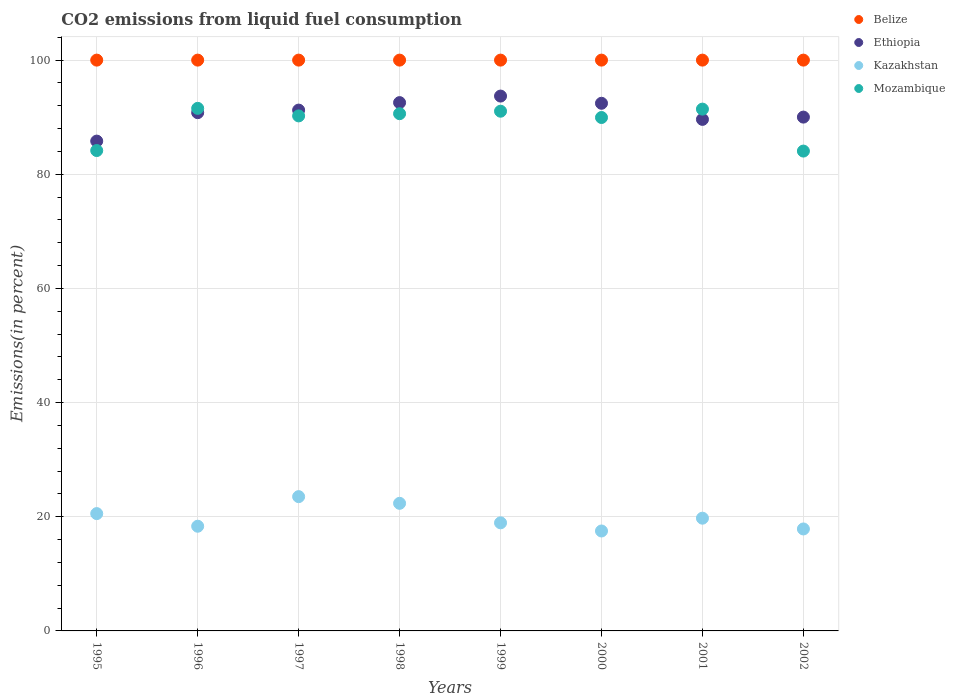What is the total CO2 emitted in Kazakhstan in 1999?
Provide a short and direct response. 18.94. Across all years, what is the maximum total CO2 emitted in Mozambique?
Ensure brevity in your answer.  91.55. Across all years, what is the minimum total CO2 emitted in Mozambique?
Your response must be concise. 84.06. What is the total total CO2 emitted in Belize in the graph?
Make the answer very short. 800. What is the difference between the total CO2 emitted in Ethiopia in 1997 and that in 2001?
Your answer should be compact. 1.63. What is the difference between the total CO2 emitted in Ethiopia in 1999 and the total CO2 emitted in Kazakhstan in 2001?
Give a very brief answer. 73.95. What is the average total CO2 emitted in Mozambique per year?
Keep it short and to the point. 89.13. In the year 1998, what is the difference between the total CO2 emitted in Ethiopia and total CO2 emitted in Kazakhstan?
Your answer should be very brief. 70.2. In how many years, is the total CO2 emitted in Kazakhstan greater than 32 %?
Keep it short and to the point. 0. What is the ratio of the total CO2 emitted in Kazakhstan in 1996 to that in 2001?
Your answer should be compact. 0.93. Is the total CO2 emitted in Mozambique in 1996 less than that in 2000?
Ensure brevity in your answer.  No. Is the difference between the total CO2 emitted in Ethiopia in 1999 and 2002 greater than the difference between the total CO2 emitted in Kazakhstan in 1999 and 2002?
Offer a very short reply. Yes. What is the difference between the highest and the second highest total CO2 emitted in Mozambique?
Offer a very short reply. 0.13. What is the difference between the highest and the lowest total CO2 emitted in Kazakhstan?
Give a very brief answer. 6.02. In how many years, is the total CO2 emitted in Kazakhstan greater than the average total CO2 emitted in Kazakhstan taken over all years?
Your answer should be very brief. 3. Is the sum of the total CO2 emitted in Kazakhstan in 2000 and 2001 greater than the maximum total CO2 emitted in Belize across all years?
Ensure brevity in your answer.  No. Is it the case that in every year, the sum of the total CO2 emitted in Ethiopia and total CO2 emitted in Kazakhstan  is greater than the sum of total CO2 emitted in Belize and total CO2 emitted in Mozambique?
Make the answer very short. Yes. Does the total CO2 emitted in Kazakhstan monotonically increase over the years?
Offer a very short reply. No. Is the total CO2 emitted in Ethiopia strictly greater than the total CO2 emitted in Mozambique over the years?
Offer a very short reply. No. Is the total CO2 emitted in Kazakhstan strictly less than the total CO2 emitted in Belize over the years?
Offer a terse response. Yes. How many dotlines are there?
Ensure brevity in your answer.  4. What is the difference between two consecutive major ticks on the Y-axis?
Your response must be concise. 20. Are the values on the major ticks of Y-axis written in scientific E-notation?
Give a very brief answer. No. Does the graph contain grids?
Make the answer very short. Yes. Where does the legend appear in the graph?
Provide a short and direct response. Top right. How many legend labels are there?
Make the answer very short. 4. What is the title of the graph?
Your answer should be very brief. CO2 emissions from liquid fuel consumption. Does "Fiji" appear as one of the legend labels in the graph?
Your answer should be very brief. No. What is the label or title of the Y-axis?
Your answer should be compact. Emissions(in percent). What is the Emissions(in percent) in Belize in 1995?
Your answer should be compact. 100. What is the Emissions(in percent) in Ethiopia in 1995?
Provide a succinct answer. 85.81. What is the Emissions(in percent) in Kazakhstan in 1995?
Make the answer very short. 20.55. What is the Emissions(in percent) of Mozambique in 1995?
Offer a very short reply. 84.16. What is the Emissions(in percent) in Belize in 1996?
Offer a terse response. 100. What is the Emissions(in percent) in Ethiopia in 1996?
Offer a terse response. 90.79. What is the Emissions(in percent) in Kazakhstan in 1996?
Offer a terse response. 18.34. What is the Emissions(in percent) of Mozambique in 1996?
Provide a short and direct response. 91.55. What is the Emissions(in percent) in Belize in 1997?
Provide a succinct answer. 100. What is the Emissions(in percent) in Ethiopia in 1997?
Your response must be concise. 91.24. What is the Emissions(in percent) of Kazakhstan in 1997?
Give a very brief answer. 23.52. What is the Emissions(in percent) of Mozambique in 1997?
Your answer should be very brief. 90.23. What is the Emissions(in percent) of Belize in 1998?
Provide a succinct answer. 100. What is the Emissions(in percent) of Ethiopia in 1998?
Your answer should be compact. 92.55. What is the Emissions(in percent) in Kazakhstan in 1998?
Make the answer very short. 22.35. What is the Emissions(in percent) in Mozambique in 1998?
Keep it short and to the point. 90.61. What is the Emissions(in percent) of Belize in 1999?
Ensure brevity in your answer.  100. What is the Emissions(in percent) in Ethiopia in 1999?
Provide a succinct answer. 93.7. What is the Emissions(in percent) in Kazakhstan in 1999?
Make the answer very short. 18.94. What is the Emissions(in percent) of Mozambique in 1999?
Ensure brevity in your answer.  91.05. What is the Emissions(in percent) of Belize in 2000?
Make the answer very short. 100. What is the Emissions(in percent) of Ethiopia in 2000?
Keep it short and to the point. 92.44. What is the Emissions(in percent) of Kazakhstan in 2000?
Offer a very short reply. 17.51. What is the Emissions(in percent) in Mozambique in 2000?
Offer a very short reply. 89.95. What is the Emissions(in percent) of Belize in 2001?
Keep it short and to the point. 100. What is the Emissions(in percent) of Ethiopia in 2001?
Keep it short and to the point. 89.62. What is the Emissions(in percent) in Kazakhstan in 2001?
Your response must be concise. 19.75. What is the Emissions(in percent) of Mozambique in 2001?
Offer a very short reply. 91.42. What is the Emissions(in percent) of Belize in 2002?
Your answer should be very brief. 100. What is the Emissions(in percent) in Ethiopia in 2002?
Keep it short and to the point. 90.02. What is the Emissions(in percent) in Kazakhstan in 2002?
Offer a terse response. 17.86. What is the Emissions(in percent) in Mozambique in 2002?
Provide a short and direct response. 84.06. Across all years, what is the maximum Emissions(in percent) in Belize?
Offer a very short reply. 100. Across all years, what is the maximum Emissions(in percent) of Ethiopia?
Give a very brief answer. 93.7. Across all years, what is the maximum Emissions(in percent) of Kazakhstan?
Provide a succinct answer. 23.52. Across all years, what is the maximum Emissions(in percent) in Mozambique?
Provide a short and direct response. 91.55. Across all years, what is the minimum Emissions(in percent) of Ethiopia?
Your answer should be very brief. 85.81. Across all years, what is the minimum Emissions(in percent) in Kazakhstan?
Your response must be concise. 17.51. Across all years, what is the minimum Emissions(in percent) of Mozambique?
Offer a terse response. 84.06. What is the total Emissions(in percent) in Belize in the graph?
Provide a short and direct response. 800. What is the total Emissions(in percent) in Ethiopia in the graph?
Your answer should be very brief. 726.18. What is the total Emissions(in percent) of Kazakhstan in the graph?
Offer a terse response. 158.83. What is the total Emissions(in percent) of Mozambique in the graph?
Your response must be concise. 713.03. What is the difference between the Emissions(in percent) of Belize in 1995 and that in 1996?
Give a very brief answer. 0. What is the difference between the Emissions(in percent) in Ethiopia in 1995 and that in 1996?
Keep it short and to the point. -4.98. What is the difference between the Emissions(in percent) of Kazakhstan in 1995 and that in 1996?
Offer a very short reply. 2.21. What is the difference between the Emissions(in percent) in Mozambique in 1995 and that in 1996?
Make the answer very short. -7.39. What is the difference between the Emissions(in percent) in Ethiopia in 1995 and that in 1997?
Provide a succinct answer. -5.43. What is the difference between the Emissions(in percent) in Kazakhstan in 1995 and that in 1997?
Keep it short and to the point. -2.97. What is the difference between the Emissions(in percent) in Mozambique in 1995 and that in 1997?
Give a very brief answer. -6.07. What is the difference between the Emissions(in percent) of Ethiopia in 1995 and that in 1998?
Offer a very short reply. -6.74. What is the difference between the Emissions(in percent) of Kazakhstan in 1995 and that in 1998?
Provide a short and direct response. -1.8. What is the difference between the Emissions(in percent) of Mozambique in 1995 and that in 1998?
Keep it short and to the point. -6.46. What is the difference between the Emissions(in percent) in Belize in 1995 and that in 1999?
Offer a terse response. 0. What is the difference between the Emissions(in percent) in Ethiopia in 1995 and that in 1999?
Offer a very short reply. -7.89. What is the difference between the Emissions(in percent) in Kazakhstan in 1995 and that in 1999?
Offer a terse response. 1.62. What is the difference between the Emissions(in percent) of Mozambique in 1995 and that in 1999?
Make the answer very short. -6.89. What is the difference between the Emissions(in percent) of Ethiopia in 1995 and that in 2000?
Your answer should be compact. -6.63. What is the difference between the Emissions(in percent) in Kazakhstan in 1995 and that in 2000?
Make the answer very short. 3.05. What is the difference between the Emissions(in percent) in Mozambique in 1995 and that in 2000?
Provide a short and direct response. -5.79. What is the difference between the Emissions(in percent) in Ethiopia in 1995 and that in 2001?
Offer a very short reply. -3.81. What is the difference between the Emissions(in percent) in Kazakhstan in 1995 and that in 2001?
Provide a short and direct response. 0.8. What is the difference between the Emissions(in percent) of Mozambique in 1995 and that in 2001?
Give a very brief answer. -7.26. What is the difference between the Emissions(in percent) of Ethiopia in 1995 and that in 2002?
Offer a terse response. -4.2. What is the difference between the Emissions(in percent) of Kazakhstan in 1995 and that in 2002?
Your answer should be compact. 2.69. What is the difference between the Emissions(in percent) of Mozambique in 1995 and that in 2002?
Provide a succinct answer. 0.09. What is the difference between the Emissions(in percent) in Belize in 1996 and that in 1997?
Offer a terse response. 0. What is the difference between the Emissions(in percent) in Ethiopia in 1996 and that in 1997?
Offer a very short reply. -0.45. What is the difference between the Emissions(in percent) in Kazakhstan in 1996 and that in 1997?
Your answer should be very brief. -5.18. What is the difference between the Emissions(in percent) of Mozambique in 1996 and that in 1997?
Keep it short and to the point. 1.32. What is the difference between the Emissions(in percent) of Ethiopia in 1996 and that in 1998?
Offer a very short reply. -1.76. What is the difference between the Emissions(in percent) in Kazakhstan in 1996 and that in 1998?
Keep it short and to the point. -4.01. What is the difference between the Emissions(in percent) in Mozambique in 1996 and that in 1998?
Provide a short and direct response. 0.93. What is the difference between the Emissions(in percent) in Belize in 1996 and that in 1999?
Offer a very short reply. 0. What is the difference between the Emissions(in percent) of Ethiopia in 1996 and that in 1999?
Provide a succinct answer. -2.91. What is the difference between the Emissions(in percent) in Kazakhstan in 1996 and that in 1999?
Your answer should be very brief. -0.6. What is the difference between the Emissions(in percent) in Mozambique in 1996 and that in 1999?
Provide a succinct answer. 0.5. What is the difference between the Emissions(in percent) in Belize in 1996 and that in 2000?
Offer a terse response. 0. What is the difference between the Emissions(in percent) of Ethiopia in 1996 and that in 2000?
Your answer should be very brief. -1.65. What is the difference between the Emissions(in percent) in Kazakhstan in 1996 and that in 2000?
Your answer should be compact. 0.83. What is the difference between the Emissions(in percent) of Mozambique in 1996 and that in 2000?
Offer a very short reply. 1.6. What is the difference between the Emissions(in percent) in Ethiopia in 1996 and that in 2001?
Provide a short and direct response. 1.18. What is the difference between the Emissions(in percent) of Kazakhstan in 1996 and that in 2001?
Give a very brief answer. -1.41. What is the difference between the Emissions(in percent) of Mozambique in 1996 and that in 2001?
Your answer should be very brief. 0.13. What is the difference between the Emissions(in percent) in Ethiopia in 1996 and that in 2002?
Make the answer very short. 0.78. What is the difference between the Emissions(in percent) in Kazakhstan in 1996 and that in 2002?
Provide a short and direct response. 0.48. What is the difference between the Emissions(in percent) in Mozambique in 1996 and that in 2002?
Provide a succinct answer. 7.48. What is the difference between the Emissions(in percent) of Ethiopia in 1997 and that in 1998?
Offer a very short reply. -1.31. What is the difference between the Emissions(in percent) in Kazakhstan in 1997 and that in 1998?
Keep it short and to the point. 1.17. What is the difference between the Emissions(in percent) of Mozambique in 1997 and that in 1998?
Provide a succinct answer. -0.39. What is the difference between the Emissions(in percent) in Belize in 1997 and that in 1999?
Keep it short and to the point. 0. What is the difference between the Emissions(in percent) of Ethiopia in 1997 and that in 1999?
Provide a short and direct response. -2.46. What is the difference between the Emissions(in percent) of Kazakhstan in 1997 and that in 1999?
Your response must be concise. 4.59. What is the difference between the Emissions(in percent) in Mozambique in 1997 and that in 1999?
Keep it short and to the point. -0.82. What is the difference between the Emissions(in percent) in Belize in 1997 and that in 2000?
Offer a terse response. 0. What is the difference between the Emissions(in percent) in Ethiopia in 1997 and that in 2000?
Your answer should be compact. -1.19. What is the difference between the Emissions(in percent) of Kazakhstan in 1997 and that in 2000?
Provide a short and direct response. 6.02. What is the difference between the Emissions(in percent) in Mozambique in 1997 and that in 2000?
Provide a succinct answer. 0.28. What is the difference between the Emissions(in percent) of Belize in 1997 and that in 2001?
Offer a very short reply. 0. What is the difference between the Emissions(in percent) of Ethiopia in 1997 and that in 2001?
Your answer should be very brief. 1.63. What is the difference between the Emissions(in percent) in Kazakhstan in 1997 and that in 2001?
Provide a short and direct response. 3.78. What is the difference between the Emissions(in percent) of Mozambique in 1997 and that in 2001?
Keep it short and to the point. -1.19. What is the difference between the Emissions(in percent) of Belize in 1997 and that in 2002?
Make the answer very short. 0. What is the difference between the Emissions(in percent) in Ethiopia in 1997 and that in 2002?
Keep it short and to the point. 1.23. What is the difference between the Emissions(in percent) of Kazakhstan in 1997 and that in 2002?
Offer a terse response. 5.66. What is the difference between the Emissions(in percent) in Mozambique in 1997 and that in 2002?
Give a very brief answer. 6.16. What is the difference between the Emissions(in percent) of Belize in 1998 and that in 1999?
Provide a short and direct response. 0. What is the difference between the Emissions(in percent) in Ethiopia in 1998 and that in 1999?
Your answer should be compact. -1.15. What is the difference between the Emissions(in percent) of Kazakhstan in 1998 and that in 1999?
Provide a short and direct response. 3.42. What is the difference between the Emissions(in percent) in Mozambique in 1998 and that in 1999?
Your answer should be compact. -0.43. What is the difference between the Emissions(in percent) in Ethiopia in 1998 and that in 2000?
Offer a terse response. 0.12. What is the difference between the Emissions(in percent) in Kazakhstan in 1998 and that in 2000?
Keep it short and to the point. 4.85. What is the difference between the Emissions(in percent) of Mozambique in 1998 and that in 2000?
Your answer should be very brief. 0.67. What is the difference between the Emissions(in percent) of Belize in 1998 and that in 2001?
Offer a terse response. 0. What is the difference between the Emissions(in percent) of Ethiopia in 1998 and that in 2001?
Provide a succinct answer. 2.94. What is the difference between the Emissions(in percent) of Kazakhstan in 1998 and that in 2001?
Provide a short and direct response. 2.6. What is the difference between the Emissions(in percent) of Mozambique in 1998 and that in 2001?
Offer a terse response. -0.8. What is the difference between the Emissions(in percent) in Ethiopia in 1998 and that in 2002?
Your answer should be compact. 2.54. What is the difference between the Emissions(in percent) of Kazakhstan in 1998 and that in 2002?
Give a very brief answer. 4.49. What is the difference between the Emissions(in percent) of Mozambique in 1998 and that in 2002?
Keep it short and to the point. 6.55. What is the difference between the Emissions(in percent) in Belize in 1999 and that in 2000?
Provide a succinct answer. 0. What is the difference between the Emissions(in percent) in Ethiopia in 1999 and that in 2000?
Keep it short and to the point. 1.26. What is the difference between the Emissions(in percent) of Kazakhstan in 1999 and that in 2000?
Provide a succinct answer. 1.43. What is the difference between the Emissions(in percent) of Mozambique in 1999 and that in 2000?
Provide a succinct answer. 1.1. What is the difference between the Emissions(in percent) of Ethiopia in 1999 and that in 2001?
Keep it short and to the point. 4.08. What is the difference between the Emissions(in percent) of Kazakhstan in 1999 and that in 2001?
Provide a short and direct response. -0.81. What is the difference between the Emissions(in percent) of Mozambique in 1999 and that in 2001?
Ensure brevity in your answer.  -0.37. What is the difference between the Emissions(in percent) of Belize in 1999 and that in 2002?
Offer a terse response. 0. What is the difference between the Emissions(in percent) of Ethiopia in 1999 and that in 2002?
Provide a short and direct response. 3.68. What is the difference between the Emissions(in percent) of Kazakhstan in 1999 and that in 2002?
Keep it short and to the point. 1.07. What is the difference between the Emissions(in percent) of Mozambique in 1999 and that in 2002?
Make the answer very short. 6.98. What is the difference between the Emissions(in percent) in Belize in 2000 and that in 2001?
Ensure brevity in your answer.  0. What is the difference between the Emissions(in percent) of Ethiopia in 2000 and that in 2001?
Offer a very short reply. 2.82. What is the difference between the Emissions(in percent) in Kazakhstan in 2000 and that in 2001?
Give a very brief answer. -2.24. What is the difference between the Emissions(in percent) of Mozambique in 2000 and that in 2001?
Your answer should be very brief. -1.47. What is the difference between the Emissions(in percent) in Belize in 2000 and that in 2002?
Your answer should be very brief. 0. What is the difference between the Emissions(in percent) of Ethiopia in 2000 and that in 2002?
Provide a succinct answer. 2.42. What is the difference between the Emissions(in percent) of Kazakhstan in 2000 and that in 2002?
Your response must be concise. -0.36. What is the difference between the Emissions(in percent) in Mozambique in 2000 and that in 2002?
Provide a short and direct response. 5.88. What is the difference between the Emissions(in percent) in Belize in 2001 and that in 2002?
Keep it short and to the point. 0. What is the difference between the Emissions(in percent) in Ethiopia in 2001 and that in 2002?
Make the answer very short. -0.4. What is the difference between the Emissions(in percent) in Kazakhstan in 2001 and that in 2002?
Ensure brevity in your answer.  1.89. What is the difference between the Emissions(in percent) of Mozambique in 2001 and that in 2002?
Offer a terse response. 7.35. What is the difference between the Emissions(in percent) in Belize in 1995 and the Emissions(in percent) in Ethiopia in 1996?
Give a very brief answer. 9.21. What is the difference between the Emissions(in percent) in Belize in 1995 and the Emissions(in percent) in Kazakhstan in 1996?
Give a very brief answer. 81.66. What is the difference between the Emissions(in percent) in Belize in 1995 and the Emissions(in percent) in Mozambique in 1996?
Offer a terse response. 8.45. What is the difference between the Emissions(in percent) in Ethiopia in 1995 and the Emissions(in percent) in Kazakhstan in 1996?
Offer a terse response. 67.47. What is the difference between the Emissions(in percent) of Ethiopia in 1995 and the Emissions(in percent) of Mozambique in 1996?
Offer a terse response. -5.74. What is the difference between the Emissions(in percent) in Kazakhstan in 1995 and the Emissions(in percent) in Mozambique in 1996?
Give a very brief answer. -71. What is the difference between the Emissions(in percent) in Belize in 1995 and the Emissions(in percent) in Ethiopia in 1997?
Your response must be concise. 8.76. What is the difference between the Emissions(in percent) of Belize in 1995 and the Emissions(in percent) of Kazakhstan in 1997?
Provide a short and direct response. 76.48. What is the difference between the Emissions(in percent) in Belize in 1995 and the Emissions(in percent) in Mozambique in 1997?
Your answer should be very brief. 9.77. What is the difference between the Emissions(in percent) in Ethiopia in 1995 and the Emissions(in percent) in Kazakhstan in 1997?
Offer a terse response. 62.29. What is the difference between the Emissions(in percent) in Ethiopia in 1995 and the Emissions(in percent) in Mozambique in 1997?
Make the answer very short. -4.42. What is the difference between the Emissions(in percent) of Kazakhstan in 1995 and the Emissions(in percent) of Mozambique in 1997?
Offer a very short reply. -69.68. What is the difference between the Emissions(in percent) in Belize in 1995 and the Emissions(in percent) in Ethiopia in 1998?
Make the answer very short. 7.45. What is the difference between the Emissions(in percent) of Belize in 1995 and the Emissions(in percent) of Kazakhstan in 1998?
Give a very brief answer. 77.65. What is the difference between the Emissions(in percent) of Belize in 1995 and the Emissions(in percent) of Mozambique in 1998?
Provide a short and direct response. 9.39. What is the difference between the Emissions(in percent) of Ethiopia in 1995 and the Emissions(in percent) of Kazakhstan in 1998?
Keep it short and to the point. 63.46. What is the difference between the Emissions(in percent) in Ethiopia in 1995 and the Emissions(in percent) in Mozambique in 1998?
Offer a terse response. -4.8. What is the difference between the Emissions(in percent) of Kazakhstan in 1995 and the Emissions(in percent) of Mozambique in 1998?
Provide a succinct answer. -70.06. What is the difference between the Emissions(in percent) of Belize in 1995 and the Emissions(in percent) of Ethiopia in 1999?
Make the answer very short. 6.3. What is the difference between the Emissions(in percent) of Belize in 1995 and the Emissions(in percent) of Kazakhstan in 1999?
Provide a succinct answer. 81.06. What is the difference between the Emissions(in percent) in Belize in 1995 and the Emissions(in percent) in Mozambique in 1999?
Your answer should be compact. 8.95. What is the difference between the Emissions(in percent) of Ethiopia in 1995 and the Emissions(in percent) of Kazakhstan in 1999?
Keep it short and to the point. 66.87. What is the difference between the Emissions(in percent) in Ethiopia in 1995 and the Emissions(in percent) in Mozambique in 1999?
Provide a succinct answer. -5.24. What is the difference between the Emissions(in percent) of Kazakhstan in 1995 and the Emissions(in percent) of Mozambique in 1999?
Offer a terse response. -70.5. What is the difference between the Emissions(in percent) in Belize in 1995 and the Emissions(in percent) in Ethiopia in 2000?
Provide a short and direct response. 7.56. What is the difference between the Emissions(in percent) in Belize in 1995 and the Emissions(in percent) in Kazakhstan in 2000?
Your response must be concise. 82.49. What is the difference between the Emissions(in percent) of Belize in 1995 and the Emissions(in percent) of Mozambique in 2000?
Make the answer very short. 10.05. What is the difference between the Emissions(in percent) in Ethiopia in 1995 and the Emissions(in percent) in Kazakhstan in 2000?
Offer a terse response. 68.3. What is the difference between the Emissions(in percent) in Ethiopia in 1995 and the Emissions(in percent) in Mozambique in 2000?
Give a very brief answer. -4.13. What is the difference between the Emissions(in percent) in Kazakhstan in 1995 and the Emissions(in percent) in Mozambique in 2000?
Give a very brief answer. -69.39. What is the difference between the Emissions(in percent) of Belize in 1995 and the Emissions(in percent) of Ethiopia in 2001?
Your answer should be very brief. 10.38. What is the difference between the Emissions(in percent) of Belize in 1995 and the Emissions(in percent) of Kazakhstan in 2001?
Make the answer very short. 80.25. What is the difference between the Emissions(in percent) in Belize in 1995 and the Emissions(in percent) in Mozambique in 2001?
Provide a succinct answer. 8.58. What is the difference between the Emissions(in percent) of Ethiopia in 1995 and the Emissions(in percent) of Kazakhstan in 2001?
Give a very brief answer. 66.06. What is the difference between the Emissions(in percent) in Ethiopia in 1995 and the Emissions(in percent) in Mozambique in 2001?
Your answer should be very brief. -5.6. What is the difference between the Emissions(in percent) in Kazakhstan in 1995 and the Emissions(in percent) in Mozambique in 2001?
Provide a succinct answer. -70.86. What is the difference between the Emissions(in percent) in Belize in 1995 and the Emissions(in percent) in Ethiopia in 2002?
Your answer should be very brief. 9.98. What is the difference between the Emissions(in percent) of Belize in 1995 and the Emissions(in percent) of Kazakhstan in 2002?
Ensure brevity in your answer.  82.14. What is the difference between the Emissions(in percent) of Belize in 1995 and the Emissions(in percent) of Mozambique in 2002?
Your response must be concise. 15.94. What is the difference between the Emissions(in percent) of Ethiopia in 1995 and the Emissions(in percent) of Kazakhstan in 2002?
Your response must be concise. 67.95. What is the difference between the Emissions(in percent) of Ethiopia in 1995 and the Emissions(in percent) of Mozambique in 2002?
Provide a short and direct response. 1.75. What is the difference between the Emissions(in percent) of Kazakhstan in 1995 and the Emissions(in percent) of Mozambique in 2002?
Offer a very short reply. -63.51. What is the difference between the Emissions(in percent) of Belize in 1996 and the Emissions(in percent) of Ethiopia in 1997?
Provide a succinct answer. 8.76. What is the difference between the Emissions(in percent) of Belize in 1996 and the Emissions(in percent) of Kazakhstan in 1997?
Provide a succinct answer. 76.48. What is the difference between the Emissions(in percent) in Belize in 1996 and the Emissions(in percent) in Mozambique in 1997?
Ensure brevity in your answer.  9.77. What is the difference between the Emissions(in percent) in Ethiopia in 1996 and the Emissions(in percent) in Kazakhstan in 1997?
Your answer should be compact. 67.27. What is the difference between the Emissions(in percent) in Ethiopia in 1996 and the Emissions(in percent) in Mozambique in 1997?
Your response must be concise. 0.57. What is the difference between the Emissions(in percent) in Kazakhstan in 1996 and the Emissions(in percent) in Mozambique in 1997?
Make the answer very short. -71.89. What is the difference between the Emissions(in percent) in Belize in 1996 and the Emissions(in percent) in Ethiopia in 1998?
Ensure brevity in your answer.  7.45. What is the difference between the Emissions(in percent) of Belize in 1996 and the Emissions(in percent) of Kazakhstan in 1998?
Your answer should be compact. 77.65. What is the difference between the Emissions(in percent) in Belize in 1996 and the Emissions(in percent) in Mozambique in 1998?
Offer a terse response. 9.39. What is the difference between the Emissions(in percent) in Ethiopia in 1996 and the Emissions(in percent) in Kazakhstan in 1998?
Provide a succinct answer. 68.44. What is the difference between the Emissions(in percent) of Ethiopia in 1996 and the Emissions(in percent) of Mozambique in 1998?
Keep it short and to the point. 0.18. What is the difference between the Emissions(in percent) in Kazakhstan in 1996 and the Emissions(in percent) in Mozambique in 1998?
Provide a succinct answer. -72.27. What is the difference between the Emissions(in percent) in Belize in 1996 and the Emissions(in percent) in Ethiopia in 1999?
Offer a very short reply. 6.3. What is the difference between the Emissions(in percent) of Belize in 1996 and the Emissions(in percent) of Kazakhstan in 1999?
Make the answer very short. 81.06. What is the difference between the Emissions(in percent) of Belize in 1996 and the Emissions(in percent) of Mozambique in 1999?
Offer a terse response. 8.95. What is the difference between the Emissions(in percent) of Ethiopia in 1996 and the Emissions(in percent) of Kazakhstan in 1999?
Make the answer very short. 71.86. What is the difference between the Emissions(in percent) of Ethiopia in 1996 and the Emissions(in percent) of Mozambique in 1999?
Provide a short and direct response. -0.26. What is the difference between the Emissions(in percent) of Kazakhstan in 1996 and the Emissions(in percent) of Mozambique in 1999?
Offer a very short reply. -72.71. What is the difference between the Emissions(in percent) in Belize in 1996 and the Emissions(in percent) in Ethiopia in 2000?
Ensure brevity in your answer.  7.56. What is the difference between the Emissions(in percent) of Belize in 1996 and the Emissions(in percent) of Kazakhstan in 2000?
Provide a short and direct response. 82.49. What is the difference between the Emissions(in percent) in Belize in 1996 and the Emissions(in percent) in Mozambique in 2000?
Offer a very short reply. 10.05. What is the difference between the Emissions(in percent) in Ethiopia in 1996 and the Emissions(in percent) in Kazakhstan in 2000?
Provide a short and direct response. 73.29. What is the difference between the Emissions(in percent) of Ethiopia in 1996 and the Emissions(in percent) of Mozambique in 2000?
Make the answer very short. 0.85. What is the difference between the Emissions(in percent) in Kazakhstan in 1996 and the Emissions(in percent) in Mozambique in 2000?
Provide a succinct answer. -71.6. What is the difference between the Emissions(in percent) of Belize in 1996 and the Emissions(in percent) of Ethiopia in 2001?
Your answer should be compact. 10.38. What is the difference between the Emissions(in percent) in Belize in 1996 and the Emissions(in percent) in Kazakhstan in 2001?
Provide a succinct answer. 80.25. What is the difference between the Emissions(in percent) in Belize in 1996 and the Emissions(in percent) in Mozambique in 2001?
Offer a very short reply. 8.58. What is the difference between the Emissions(in percent) in Ethiopia in 1996 and the Emissions(in percent) in Kazakhstan in 2001?
Ensure brevity in your answer.  71.04. What is the difference between the Emissions(in percent) of Ethiopia in 1996 and the Emissions(in percent) of Mozambique in 2001?
Keep it short and to the point. -0.62. What is the difference between the Emissions(in percent) of Kazakhstan in 1996 and the Emissions(in percent) of Mozambique in 2001?
Keep it short and to the point. -73.07. What is the difference between the Emissions(in percent) in Belize in 1996 and the Emissions(in percent) in Ethiopia in 2002?
Provide a short and direct response. 9.98. What is the difference between the Emissions(in percent) of Belize in 1996 and the Emissions(in percent) of Kazakhstan in 2002?
Ensure brevity in your answer.  82.14. What is the difference between the Emissions(in percent) in Belize in 1996 and the Emissions(in percent) in Mozambique in 2002?
Ensure brevity in your answer.  15.94. What is the difference between the Emissions(in percent) in Ethiopia in 1996 and the Emissions(in percent) in Kazakhstan in 2002?
Provide a short and direct response. 72.93. What is the difference between the Emissions(in percent) of Ethiopia in 1996 and the Emissions(in percent) of Mozambique in 2002?
Your response must be concise. 6.73. What is the difference between the Emissions(in percent) in Kazakhstan in 1996 and the Emissions(in percent) in Mozambique in 2002?
Ensure brevity in your answer.  -65.72. What is the difference between the Emissions(in percent) in Belize in 1997 and the Emissions(in percent) in Ethiopia in 1998?
Your answer should be very brief. 7.45. What is the difference between the Emissions(in percent) of Belize in 1997 and the Emissions(in percent) of Kazakhstan in 1998?
Offer a very short reply. 77.65. What is the difference between the Emissions(in percent) in Belize in 1997 and the Emissions(in percent) in Mozambique in 1998?
Offer a very short reply. 9.39. What is the difference between the Emissions(in percent) of Ethiopia in 1997 and the Emissions(in percent) of Kazakhstan in 1998?
Your answer should be very brief. 68.89. What is the difference between the Emissions(in percent) of Ethiopia in 1997 and the Emissions(in percent) of Mozambique in 1998?
Your response must be concise. 0.63. What is the difference between the Emissions(in percent) in Kazakhstan in 1997 and the Emissions(in percent) in Mozambique in 1998?
Offer a very short reply. -67.09. What is the difference between the Emissions(in percent) in Belize in 1997 and the Emissions(in percent) in Ethiopia in 1999?
Offer a terse response. 6.3. What is the difference between the Emissions(in percent) in Belize in 1997 and the Emissions(in percent) in Kazakhstan in 1999?
Offer a terse response. 81.06. What is the difference between the Emissions(in percent) of Belize in 1997 and the Emissions(in percent) of Mozambique in 1999?
Provide a succinct answer. 8.95. What is the difference between the Emissions(in percent) of Ethiopia in 1997 and the Emissions(in percent) of Kazakhstan in 1999?
Give a very brief answer. 72.31. What is the difference between the Emissions(in percent) in Ethiopia in 1997 and the Emissions(in percent) in Mozambique in 1999?
Provide a short and direct response. 0.2. What is the difference between the Emissions(in percent) of Kazakhstan in 1997 and the Emissions(in percent) of Mozambique in 1999?
Your response must be concise. -67.52. What is the difference between the Emissions(in percent) of Belize in 1997 and the Emissions(in percent) of Ethiopia in 2000?
Make the answer very short. 7.56. What is the difference between the Emissions(in percent) of Belize in 1997 and the Emissions(in percent) of Kazakhstan in 2000?
Give a very brief answer. 82.49. What is the difference between the Emissions(in percent) in Belize in 1997 and the Emissions(in percent) in Mozambique in 2000?
Provide a short and direct response. 10.05. What is the difference between the Emissions(in percent) of Ethiopia in 1997 and the Emissions(in percent) of Kazakhstan in 2000?
Your response must be concise. 73.74. What is the difference between the Emissions(in percent) of Ethiopia in 1997 and the Emissions(in percent) of Mozambique in 2000?
Your response must be concise. 1.3. What is the difference between the Emissions(in percent) of Kazakhstan in 1997 and the Emissions(in percent) of Mozambique in 2000?
Keep it short and to the point. -66.42. What is the difference between the Emissions(in percent) of Belize in 1997 and the Emissions(in percent) of Ethiopia in 2001?
Your answer should be very brief. 10.38. What is the difference between the Emissions(in percent) of Belize in 1997 and the Emissions(in percent) of Kazakhstan in 2001?
Provide a succinct answer. 80.25. What is the difference between the Emissions(in percent) in Belize in 1997 and the Emissions(in percent) in Mozambique in 2001?
Make the answer very short. 8.58. What is the difference between the Emissions(in percent) in Ethiopia in 1997 and the Emissions(in percent) in Kazakhstan in 2001?
Make the answer very short. 71.5. What is the difference between the Emissions(in percent) in Ethiopia in 1997 and the Emissions(in percent) in Mozambique in 2001?
Provide a short and direct response. -0.17. What is the difference between the Emissions(in percent) of Kazakhstan in 1997 and the Emissions(in percent) of Mozambique in 2001?
Ensure brevity in your answer.  -67.89. What is the difference between the Emissions(in percent) in Belize in 1997 and the Emissions(in percent) in Ethiopia in 2002?
Make the answer very short. 9.98. What is the difference between the Emissions(in percent) of Belize in 1997 and the Emissions(in percent) of Kazakhstan in 2002?
Offer a very short reply. 82.14. What is the difference between the Emissions(in percent) of Belize in 1997 and the Emissions(in percent) of Mozambique in 2002?
Your answer should be very brief. 15.94. What is the difference between the Emissions(in percent) in Ethiopia in 1997 and the Emissions(in percent) in Kazakhstan in 2002?
Your response must be concise. 73.38. What is the difference between the Emissions(in percent) of Ethiopia in 1997 and the Emissions(in percent) of Mozambique in 2002?
Provide a short and direct response. 7.18. What is the difference between the Emissions(in percent) of Kazakhstan in 1997 and the Emissions(in percent) of Mozambique in 2002?
Offer a very short reply. -60.54. What is the difference between the Emissions(in percent) of Belize in 1998 and the Emissions(in percent) of Ethiopia in 1999?
Offer a very short reply. 6.3. What is the difference between the Emissions(in percent) in Belize in 1998 and the Emissions(in percent) in Kazakhstan in 1999?
Ensure brevity in your answer.  81.06. What is the difference between the Emissions(in percent) in Belize in 1998 and the Emissions(in percent) in Mozambique in 1999?
Your answer should be very brief. 8.95. What is the difference between the Emissions(in percent) of Ethiopia in 1998 and the Emissions(in percent) of Kazakhstan in 1999?
Provide a short and direct response. 73.62. What is the difference between the Emissions(in percent) in Ethiopia in 1998 and the Emissions(in percent) in Mozambique in 1999?
Provide a short and direct response. 1.51. What is the difference between the Emissions(in percent) of Kazakhstan in 1998 and the Emissions(in percent) of Mozambique in 1999?
Give a very brief answer. -68.69. What is the difference between the Emissions(in percent) of Belize in 1998 and the Emissions(in percent) of Ethiopia in 2000?
Provide a succinct answer. 7.56. What is the difference between the Emissions(in percent) in Belize in 1998 and the Emissions(in percent) in Kazakhstan in 2000?
Your response must be concise. 82.49. What is the difference between the Emissions(in percent) of Belize in 1998 and the Emissions(in percent) of Mozambique in 2000?
Provide a succinct answer. 10.05. What is the difference between the Emissions(in percent) of Ethiopia in 1998 and the Emissions(in percent) of Kazakhstan in 2000?
Your answer should be compact. 75.05. What is the difference between the Emissions(in percent) in Ethiopia in 1998 and the Emissions(in percent) in Mozambique in 2000?
Provide a succinct answer. 2.61. What is the difference between the Emissions(in percent) in Kazakhstan in 1998 and the Emissions(in percent) in Mozambique in 2000?
Make the answer very short. -67.59. What is the difference between the Emissions(in percent) of Belize in 1998 and the Emissions(in percent) of Ethiopia in 2001?
Offer a very short reply. 10.38. What is the difference between the Emissions(in percent) of Belize in 1998 and the Emissions(in percent) of Kazakhstan in 2001?
Your response must be concise. 80.25. What is the difference between the Emissions(in percent) of Belize in 1998 and the Emissions(in percent) of Mozambique in 2001?
Provide a short and direct response. 8.58. What is the difference between the Emissions(in percent) in Ethiopia in 1998 and the Emissions(in percent) in Kazakhstan in 2001?
Provide a succinct answer. 72.81. What is the difference between the Emissions(in percent) of Ethiopia in 1998 and the Emissions(in percent) of Mozambique in 2001?
Your response must be concise. 1.14. What is the difference between the Emissions(in percent) in Kazakhstan in 1998 and the Emissions(in percent) in Mozambique in 2001?
Keep it short and to the point. -69.06. What is the difference between the Emissions(in percent) in Belize in 1998 and the Emissions(in percent) in Ethiopia in 2002?
Make the answer very short. 9.98. What is the difference between the Emissions(in percent) of Belize in 1998 and the Emissions(in percent) of Kazakhstan in 2002?
Provide a succinct answer. 82.14. What is the difference between the Emissions(in percent) in Belize in 1998 and the Emissions(in percent) in Mozambique in 2002?
Ensure brevity in your answer.  15.94. What is the difference between the Emissions(in percent) of Ethiopia in 1998 and the Emissions(in percent) of Kazakhstan in 2002?
Provide a short and direct response. 74.69. What is the difference between the Emissions(in percent) of Ethiopia in 1998 and the Emissions(in percent) of Mozambique in 2002?
Give a very brief answer. 8.49. What is the difference between the Emissions(in percent) of Kazakhstan in 1998 and the Emissions(in percent) of Mozambique in 2002?
Your response must be concise. -61.71. What is the difference between the Emissions(in percent) in Belize in 1999 and the Emissions(in percent) in Ethiopia in 2000?
Provide a short and direct response. 7.56. What is the difference between the Emissions(in percent) in Belize in 1999 and the Emissions(in percent) in Kazakhstan in 2000?
Give a very brief answer. 82.49. What is the difference between the Emissions(in percent) in Belize in 1999 and the Emissions(in percent) in Mozambique in 2000?
Keep it short and to the point. 10.05. What is the difference between the Emissions(in percent) in Ethiopia in 1999 and the Emissions(in percent) in Kazakhstan in 2000?
Offer a very short reply. 76.19. What is the difference between the Emissions(in percent) in Ethiopia in 1999 and the Emissions(in percent) in Mozambique in 2000?
Provide a succinct answer. 3.75. What is the difference between the Emissions(in percent) of Kazakhstan in 1999 and the Emissions(in percent) of Mozambique in 2000?
Offer a terse response. -71.01. What is the difference between the Emissions(in percent) of Belize in 1999 and the Emissions(in percent) of Ethiopia in 2001?
Give a very brief answer. 10.38. What is the difference between the Emissions(in percent) in Belize in 1999 and the Emissions(in percent) in Kazakhstan in 2001?
Provide a short and direct response. 80.25. What is the difference between the Emissions(in percent) of Belize in 1999 and the Emissions(in percent) of Mozambique in 2001?
Keep it short and to the point. 8.58. What is the difference between the Emissions(in percent) in Ethiopia in 1999 and the Emissions(in percent) in Kazakhstan in 2001?
Make the answer very short. 73.95. What is the difference between the Emissions(in percent) in Ethiopia in 1999 and the Emissions(in percent) in Mozambique in 2001?
Give a very brief answer. 2.28. What is the difference between the Emissions(in percent) in Kazakhstan in 1999 and the Emissions(in percent) in Mozambique in 2001?
Give a very brief answer. -72.48. What is the difference between the Emissions(in percent) of Belize in 1999 and the Emissions(in percent) of Ethiopia in 2002?
Your response must be concise. 9.98. What is the difference between the Emissions(in percent) in Belize in 1999 and the Emissions(in percent) in Kazakhstan in 2002?
Keep it short and to the point. 82.14. What is the difference between the Emissions(in percent) in Belize in 1999 and the Emissions(in percent) in Mozambique in 2002?
Keep it short and to the point. 15.94. What is the difference between the Emissions(in percent) of Ethiopia in 1999 and the Emissions(in percent) of Kazakhstan in 2002?
Offer a very short reply. 75.84. What is the difference between the Emissions(in percent) in Ethiopia in 1999 and the Emissions(in percent) in Mozambique in 2002?
Give a very brief answer. 9.64. What is the difference between the Emissions(in percent) of Kazakhstan in 1999 and the Emissions(in percent) of Mozambique in 2002?
Give a very brief answer. -65.13. What is the difference between the Emissions(in percent) in Belize in 2000 and the Emissions(in percent) in Ethiopia in 2001?
Your response must be concise. 10.38. What is the difference between the Emissions(in percent) of Belize in 2000 and the Emissions(in percent) of Kazakhstan in 2001?
Give a very brief answer. 80.25. What is the difference between the Emissions(in percent) of Belize in 2000 and the Emissions(in percent) of Mozambique in 2001?
Offer a terse response. 8.58. What is the difference between the Emissions(in percent) in Ethiopia in 2000 and the Emissions(in percent) in Kazakhstan in 2001?
Your answer should be compact. 72.69. What is the difference between the Emissions(in percent) of Ethiopia in 2000 and the Emissions(in percent) of Mozambique in 2001?
Give a very brief answer. 1.02. What is the difference between the Emissions(in percent) in Kazakhstan in 2000 and the Emissions(in percent) in Mozambique in 2001?
Offer a terse response. -73.91. What is the difference between the Emissions(in percent) in Belize in 2000 and the Emissions(in percent) in Ethiopia in 2002?
Offer a terse response. 9.98. What is the difference between the Emissions(in percent) of Belize in 2000 and the Emissions(in percent) of Kazakhstan in 2002?
Offer a terse response. 82.14. What is the difference between the Emissions(in percent) of Belize in 2000 and the Emissions(in percent) of Mozambique in 2002?
Keep it short and to the point. 15.94. What is the difference between the Emissions(in percent) of Ethiopia in 2000 and the Emissions(in percent) of Kazakhstan in 2002?
Provide a short and direct response. 74.57. What is the difference between the Emissions(in percent) in Ethiopia in 2000 and the Emissions(in percent) in Mozambique in 2002?
Make the answer very short. 8.37. What is the difference between the Emissions(in percent) of Kazakhstan in 2000 and the Emissions(in percent) of Mozambique in 2002?
Keep it short and to the point. -66.56. What is the difference between the Emissions(in percent) in Belize in 2001 and the Emissions(in percent) in Ethiopia in 2002?
Offer a very short reply. 9.98. What is the difference between the Emissions(in percent) in Belize in 2001 and the Emissions(in percent) in Kazakhstan in 2002?
Make the answer very short. 82.14. What is the difference between the Emissions(in percent) of Belize in 2001 and the Emissions(in percent) of Mozambique in 2002?
Keep it short and to the point. 15.94. What is the difference between the Emissions(in percent) of Ethiopia in 2001 and the Emissions(in percent) of Kazakhstan in 2002?
Keep it short and to the point. 71.75. What is the difference between the Emissions(in percent) of Ethiopia in 2001 and the Emissions(in percent) of Mozambique in 2002?
Make the answer very short. 5.55. What is the difference between the Emissions(in percent) of Kazakhstan in 2001 and the Emissions(in percent) of Mozambique in 2002?
Provide a succinct answer. -64.32. What is the average Emissions(in percent) in Belize per year?
Your answer should be very brief. 100. What is the average Emissions(in percent) of Ethiopia per year?
Your answer should be compact. 90.77. What is the average Emissions(in percent) in Kazakhstan per year?
Keep it short and to the point. 19.85. What is the average Emissions(in percent) of Mozambique per year?
Offer a very short reply. 89.13. In the year 1995, what is the difference between the Emissions(in percent) of Belize and Emissions(in percent) of Ethiopia?
Give a very brief answer. 14.19. In the year 1995, what is the difference between the Emissions(in percent) in Belize and Emissions(in percent) in Kazakhstan?
Ensure brevity in your answer.  79.45. In the year 1995, what is the difference between the Emissions(in percent) in Belize and Emissions(in percent) in Mozambique?
Ensure brevity in your answer.  15.84. In the year 1995, what is the difference between the Emissions(in percent) in Ethiopia and Emissions(in percent) in Kazakhstan?
Give a very brief answer. 65.26. In the year 1995, what is the difference between the Emissions(in percent) of Ethiopia and Emissions(in percent) of Mozambique?
Offer a very short reply. 1.65. In the year 1995, what is the difference between the Emissions(in percent) of Kazakhstan and Emissions(in percent) of Mozambique?
Give a very brief answer. -63.61. In the year 1996, what is the difference between the Emissions(in percent) of Belize and Emissions(in percent) of Ethiopia?
Offer a very short reply. 9.21. In the year 1996, what is the difference between the Emissions(in percent) in Belize and Emissions(in percent) in Kazakhstan?
Ensure brevity in your answer.  81.66. In the year 1996, what is the difference between the Emissions(in percent) of Belize and Emissions(in percent) of Mozambique?
Provide a succinct answer. 8.45. In the year 1996, what is the difference between the Emissions(in percent) in Ethiopia and Emissions(in percent) in Kazakhstan?
Ensure brevity in your answer.  72.45. In the year 1996, what is the difference between the Emissions(in percent) of Ethiopia and Emissions(in percent) of Mozambique?
Offer a very short reply. -0.76. In the year 1996, what is the difference between the Emissions(in percent) in Kazakhstan and Emissions(in percent) in Mozambique?
Your answer should be very brief. -73.21. In the year 1997, what is the difference between the Emissions(in percent) in Belize and Emissions(in percent) in Ethiopia?
Keep it short and to the point. 8.76. In the year 1997, what is the difference between the Emissions(in percent) of Belize and Emissions(in percent) of Kazakhstan?
Your answer should be compact. 76.48. In the year 1997, what is the difference between the Emissions(in percent) of Belize and Emissions(in percent) of Mozambique?
Provide a short and direct response. 9.77. In the year 1997, what is the difference between the Emissions(in percent) of Ethiopia and Emissions(in percent) of Kazakhstan?
Provide a succinct answer. 67.72. In the year 1997, what is the difference between the Emissions(in percent) of Ethiopia and Emissions(in percent) of Mozambique?
Your response must be concise. 1.02. In the year 1997, what is the difference between the Emissions(in percent) in Kazakhstan and Emissions(in percent) in Mozambique?
Keep it short and to the point. -66.7. In the year 1998, what is the difference between the Emissions(in percent) in Belize and Emissions(in percent) in Ethiopia?
Offer a very short reply. 7.45. In the year 1998, what is the difference between the Emissions(in percent) of Belize and Emissions(in percent) of Kazakhstan?
Your answer should be very brief. 77.65. In the year 1998, what is the difference between the Emissions(in percent) of Belize and Emissions(in percent) of Mozambique?
Offer a very short reply. 9.39. In the year 1998, what is the difference between the Emissions(in percent) of Ethiopia and Emissions(in percent) of Kazakhstan?
Make the answer very short. 70.2. In the year 1998, what is the difference between the Emissions(in percent) in Ethiopia and Emissions(in percent) in Mozambique?
Your response must be concise. 1.94. In the year 1998, what is the difference between the Emissions(in percent) in Kazakhstan and Emissions(in percent) in Mozambique?
Provide a short and direct response. -68.26. In the year 1999, what is the difference between the Emissions(in percent) in Belize and Emissions(in percent) in Ethiopia?
Make the answer very short. 6.3. In the year 1999, what is the difference between the Emissions(in percent) of Belize and Emissions(in percent) of Kazakhstan?
Your response must be concise. 81.06. In the year 1999, what is the difference between the Emissions(in percent) of Belize and Emissions(in percent) of Mozambique?
Your response must be concise. 8.95. In the year 1999, what is the difference between the Emissions(in percent) of Ethiopia and Emissions(in percent) of Kazakhstan?
Offer a terse response. 74.76. In the year 1999, what is the difference between the Emissions(in percent) in Ethiopia and Emissions(in percent) in Mozambique?
Provide a short and direct response. 2.65. In the year 1999, what is the difference between the Emissions(in percent) in Kazakhstan and Emissions(in percent) in Mozambique?
Make the answer very short. -72.11. In the year 2000, what is the difference between the Emissions(in percent) of Belize and Emissions(in percent) of Ethiopia?
Your answer should be very brief. 7.56. In the year 2000, what is the difference between the Emissions(in percent) of Belize and Emissions(in percent) of Kazakhstan?
Give a very brief answer. 82.49. In the year 2000, what is the difference between the Emissions(in percent) of Belize and Emissions(in percent) of Mozambique?
Your answer should be very brief. 10.05. In the year 2000, what is the difference between the Emissions(in percent) of Ethiopia and Emissions(in percent) of Kazakhstan?
Make the answer very short. 74.93. In the year 2000, what is the difference between the Emissions(in percent) in Ethiopia and Emissions(in percent) in Mozambique?
Your answer should be compact. 2.49. In the year 2000, what is the difference between the Emissions(in percent) of Kazakhstan and Emissions(in percent) of Mozambique?
Offer a terse response. -72.44. In the year 2001, what is the difference between the Emissions(in percent) in Belize and Emissions(in percent) in Ethiopia?
Give a very brief answer. 10.38. In the year 2001, what is the difference between the Emissions(in percent) in Belize and Emissions(in percent) in Kazakhstan?
Keep it short and to the point. 80.25. In the year 2001, what is the difference between the Emissions(in percent) in Belize and Emissions(in percent) in Mozambique?
Give a very brief answer. 8.58. In the year 2001, what is the difference between the Emissions(in percent) in Ethiopia and Emissions(in percent) in Kazakhstan?
Your answer should be very brief. 69.87. In the year 2001, what is the difference between the Emissions(in percent) of Ethiopia and Emissions(in percent) of Mozambique?
Give a very brief answer. -1.8. In the year 2001, what is the difference between the Emissions(in percent) of Kazakhstan and Emissions(in percent) of Mozambique?
Keep it short and to the point. -71.67. In the year 2002, what is the difference between the Emissions(in percent) of Belize and Emissions(in percent) of Ethiopia?
Offer a terse response. 9.98. In the year 2002, what is the difference between the Emissions(in percent) in Belize and Emissions(in percent) in Kazakhstan?
Give a very brief answer. 82.14. In the year 2002, what is the difference between the Emissions(in percent) in Belize and Emissions(in percent) in Mozambique?
Offer a terse response. 15.94. In the year 2002, what is the difference between the Emissions(in percent) of Ethiopia and Emissions(in percent) of Kazakhstan?
Your answer should be compact. 72.15. In the year 2002, what is the difference between the Emissions(in percent) of Ethiopia and Emissions(in percent) of Mozambique?
Provide a succinct answer. 5.95. In the year 2002, what is the difference between the Emissions(in percent) in Kazakhstan and Emissions(in percent) in Mozambique?
Your answer should be compact. -66.2. What is the ratio of the Emissions(in percent) of Ethiopia in 1995 to that in 1996?
Provide a succinct answer. 0.95. What is the ratio of the Emissions(in percent) in Kazakhstan in 1995 to that in 1996?
Provide a succinct answer. 1.12. What is the ratio of the Emissions(in percent) of Mozambique in 1995 to that in 1996?
Give a very brief answer. 0.92. What is the ratio of the Emissions(in percent) in Ethiopia in 1995 to that in 1997?
Your response must be concise. 0.94. What is the ratio of the Emissions(in percent) of Kazakhstan in 1995 to that in 1997?
Offer a very short reply. 0.87. What is the ratio of the Emissions(in percent) of Mozambique in 1995 to that in 1997?
Keep it short and to the point. 0.93. What is the ratio of the Emissions(in percent) in Ethiopia in 1995 to that in 1998?
Your answer should be compact. 0.93. What is the ratio of the Emissions(in percent) of Kazakhstan in 1995 to that in 1998?
Your answer should be compact. 0.92. What is the ratio of the Emissions(in percent) of Mozambique in 1995 to that in 1998?
Give a very brief answer. 0.93. What is the ratio of the Emissions(in percent) in Ethiopia in 1995 to that in 1999?
Ensure brevity in your answer.  0.92. What is the ratio of the Emissions(in percent) in Kazakhstan in 1995 to that in 1999?
Your answer should be compact. 1.09. What is the ratio of the Emissions(in percent) in Mozambique in 1995 to that in 1999?
Provide a short and direct response. 0.92. What is the ratio of the Emissions(in percent) in Ethiopia in 1995 to that in 2000?
Keep it short and to the point. 0.93. What is the ratio of the Emissions(in percent) of Kazakhstan in 1995 to that in 2000?
Make the answer very short. 1.17. What is the ratio of the Emissions(in percent) in Mozambique in 1995 to that in 2000?
Offer a terse response. 0.94. What is the ratio of the Emissions(in percent) of Belize in 1995 to that in 2001?
Keep it short and to the point. 1. What is the ratio of the Emissions(in percent) of Ethiopia in 1995 to that in 2001?
Your answer should be very brief. 0.96. What is the ratio of the Emissions(in percent) of Kazakhstan in 1995 to that in 2001?
Provide a short and direct response. 1.04. What is the ratio of the Emissions(in percent) in Mozambique in 1995 to that in 2001?
Your answer should be compact. 0.92. What is the ratio of the Emissions(in percent) in Belize in 1995 to that in 2002?
Your response must be concise. 1. What is the ratio of the Emissions(in percent) in Ethiopia in 1995 to that in 2002?
Offer a very short reply. 0.95. What is the ratio of the Emissions(in percent) in Kazakhstan in 1995 to that in 2002?
Provide a succinct answer. 1.15. What is the ratio of the Emissions(in percent) in Ethiopia in 1996 to that in 1997?
Keep it short and to the point. 1. What is the ratio of the Emissions(in percent) of Kazakhstan in 1996 to that in 1997?
Make the answer very short. 0.78. What is the ratio of the Emissions(in percent) of Mozambique in 1996 to that in 1997?
Your response must be concise. 1.01. What is the ratio of the Emissions(in percent) in Ethiopia in 1996 to that in 1998?
Ensure brevity in your answer.  0.98. What is the ratio of the Emissions(in percent) of Kazakhstan in 1996 to that in 1998?
Offer a terse response. 0.82. What is the ratio of the Emissions(in percent) of Mozambique in 1996 to that in 1998?
Keep it short and to the point. 1.01. What is the ratio of the Emissions(in percent) of Ethiopia in 1996 to that in 1999?
Provide a short and direct response. 0.97. What is the ratio of the Emissions(in percent) in Kazakhstan in 1996 to that in 1999?
Give a very brief answer. 0.97. What is the ratio of the Emissions(in percent) in Mozambique in 1996 to that in 1999?
Your response must be concise. 1.01. What is the ratio of the Emissions(in percent) in Ethiopia in 1996 to that in 2000?
Provide a short and direct response. 0.98. What is the ratio of the Emissions(in percent) of Kazakhstan in 1996 to that in 2000?
Offer a terse response. 1.05. What is the ratio of the Emissions(in percent) in Mozambique in 1996 to that in 2000?
Your answer should be very brief. 1.02. What is the ratio of the Emissions(in percent) in Belize in 1996 to that in 2001?
Offer a very short reply. 1. What is the ratio of the Emissions(in percent) of Ethiopia in 1996 to that in 2001?
Ensure brevity in your answer.  1.01. What is the ratio of the Emissions(in percent) of Kazakhstan in 1996 to that in 2001?
Keep it short and to the point. 0.93. What is the ratio of the Emissions(in percent) of Ethiopia in 1996 to that in 2002?
Offer a terse response. 1.01. What is the ratio of the Emissions(in percent) of Kazakhstan in 1996 to that in 2002?
Provide a short and direct response. 1.03. What is the ratio of the Emissions(in percent) of Mozambique in 1996 to that in 2002?
Your answer should be very brief. 1.09. What is the ratio of the Emissions(in percent) in Ethiopia in 1997 to that in 1998?
Provide a succinct answer. 0.99. What is the ratio of the Emissions(in percent) of Kazakhstan in 1997 to that in 1998?
Keep it short and to the point. 1.05. What is the ratio of the Emissions(in percent) in Mozambique in 1997 to that in 1998?
Your response must be concise. 1. What is the ratio of the Emissions(in percent) of Belize in 1997 to that in 1999?
Give a very brief answer. 1. What is the ratio of the Emissions(in percent) of Ethiopia in 1997 to that in 1999?
Your answer should be very brief. 0.97. What is the ratio of the Emissions(in percent) of Kazakhstan in 1997 to that in 1999?
Offer a very short reply. 1.24. What is the ratio of the Emissions(in percent) in Belize in 1997 to that in 2000?
Your response must be concise. 1. What is the ratio of the Emissions(in percent) of Ethiopia in 1997 to that in 2000?
Provide a short and direct response. 0.99. What is the ratio of the Emissions(in percent) of Kazakhstan in 1997 to that in 2000?
Ensure brevity in your answer.  1.34. What is the ratio of the Emissions(in percent) in Mozambique in 1997 to that in 2000?
Offer a very short reply. 1. What is the ratio of the Emissions(in percent) of Belize in 1997 to that in 2001?
Ensure brevity in your answer.  1. What is the ratio of the Emissions(in percent) of Ethiopia in 1997 to that in 2001?
Provide a short and direct response. 1.02. What is the ratio of the Emissions(in percent) in Kazakhstan in 1997 to that in 2001?
Your answer should be compact. 1.19. What is the ratio of the Emissions(in percent) in Ethiopia in 1997 to that in 2002?
Keep it short and to the point. 1.01. What is the ratio of the Emissions(in percent) of Kazakhstan in 1997 to that in 2002?
Give a very brief answer. 1.32. What is the ratio of the Emissions(in percent) in Mozambique in 1997 to that in 2002?
Your answer should be compact. 1.07. What is the ratio of the Emissions(in percent) of Belize in 1998 to that in 1999?
Your answer should be very brief. 1. What is the ratio of the Emissions(in percent) in Ethiopia in 1998 to that in 1999?
Give a very brief answer. 0.99. What is the ratio of the Emissions(in percent) in Kazakhstan in 1998 to that in 1999?
Provide a short and direct response. 1.18. What is the ratio of the Emissions(in percent) in Kazakhstan in 1998 to that in 2000?
Provide a short and direct response. 1.28. What is the ratio of the Emissions(in percent) in Mozambique in 1998 to that in 2000?
Keep it short and to the point. 1.01. What is the ratio of the Emissions(in percent) of Belize in 1998 to that in 2001?
Offer a very short reply. 1. What is the ratio of the Emissions(in percent) of Ethiopia in 1998 to that in 2001?
Make the answer very short. 1.03. What is the ratio of the Emissions(in percent) of Kazakhstan in 1998 to that in 2001?
Offer a very short reply. 1.13. What is the ratio of the Emissions(in percent) in Ethiopia in 1998 to that in 2002?
Your answer should be very brief. 1.03. What is the ratio of the Emissions(in percent) in Kazakhstan in 1998 to that in 2002?
Provide a succinct answer. 1.25. What is the ratio of the Emissions(in percent) of Mozambique in 1998 to that in 2002?
Your answer should be compact. 1.08. What is the ratio of the Emissions(in percent) in Ethiopia in 1999 to that in 2000?
Provide a short and direct response. 1.01. What is the ratio of the Emissions(in percent) of Kazakhstan in 1999 to that in 2000?
Give a very brief answer. 1.08. What is the ratio of the Emissions(in percent) of Mozambique in 1999 to that in 2000?
Your answer should be compact. 1.01. What is the ratio of the Emissions(in percent) in Ethiopia in 1999 to that in 2001?
Your answer should be compact. 1.05. What is the ratio of the Emissions(in percent) in Kazakhstan in 1999 to that in 2001?
Make the answer very short. 0.96. What is the ratio of the Emissions(in percent) in Mozambique in 1999 to that in 2001?
Keep it short and to the point. 1. What is the ratio of the Emissions(in percent) of Ethiopia in 1999 to that in 2002?
Ensure brevity in your answer.  1.04. What is the ratio of the Emissions(in percent) of Kazakhstan in 1999 to that in 2002?
Ensure brevity in your answer.  1.06. What is the ratio of the Emissions(in percent) of Mozambique in 1999 to that in 2002?
Make the answer very short. 1.08. What is the ratio of the Emissions(in percent) of Belize in 2000 to that in 2001?
Offer a very short reply. 1. What is the ratio of the Emissions(in percent) of Ethiopia in 2000 to that in 2001?
Keep it short and to the point. 1.03. What is the ratio of the Emissions(in percent) in Kazakhstan in 2000 to that in 2001?
Ensure brevity in your answer.  0.89. What is the ratio of the Emissions(in percent) of Mozambique in 2000 to that in 2001?
Offer a very short reply. 0.98. What is the ratio of the Emissions(in percent) of Ethiopia in 2000 to that in 2002?
Your answer should be compact. 1.03. What is the ratio of the Emissions(in percent) of Mozambique in 2000 to that in 2002?
Ensure brevity in your answer.  1.07. What is the ratio of the Emissions(in percent) in Belize in 2001 to that in 2002?
Offer a very short reply. 1. What is the ratio of the Emissions(in percent) of Kazakhstan in 2001 to that in 2002?
Give a very brief answer. 1.11. What is the ratio of the Emissions(in percent) of Mozambique in 2001 to that in 2002?
Provide a short and direct response. 1.09. What is the difference between the highest and the second highest Emissions(in percent) of Belize?
Offer a very short reply. 0. What is the difference between the highest and the second highest Emissions(in percent) in Ethiopia?
Offer a very short reply. 1.15. What is the difference between the highest and the second highest Emissions(in percent) of Kazakhstan?
Your answer should be very brief. 1.17. What is the difference between the highest and the second highest Emissions(in percent) of Mozambique?
Your answer should be compact. 0.13. What is the difference between the highest and the lowest Emissions(in percent) in Ethiopia?
Offer a terse response. 7.89. What is the difference between the highest and the lowest Emissions(in percent) of Kazakhstan?
Offer a very short reply. 6.02. What is the difference between the highest and the lowest Emissions(in percent) in Mozambique?
Provide a succinct answer. 7.48. 